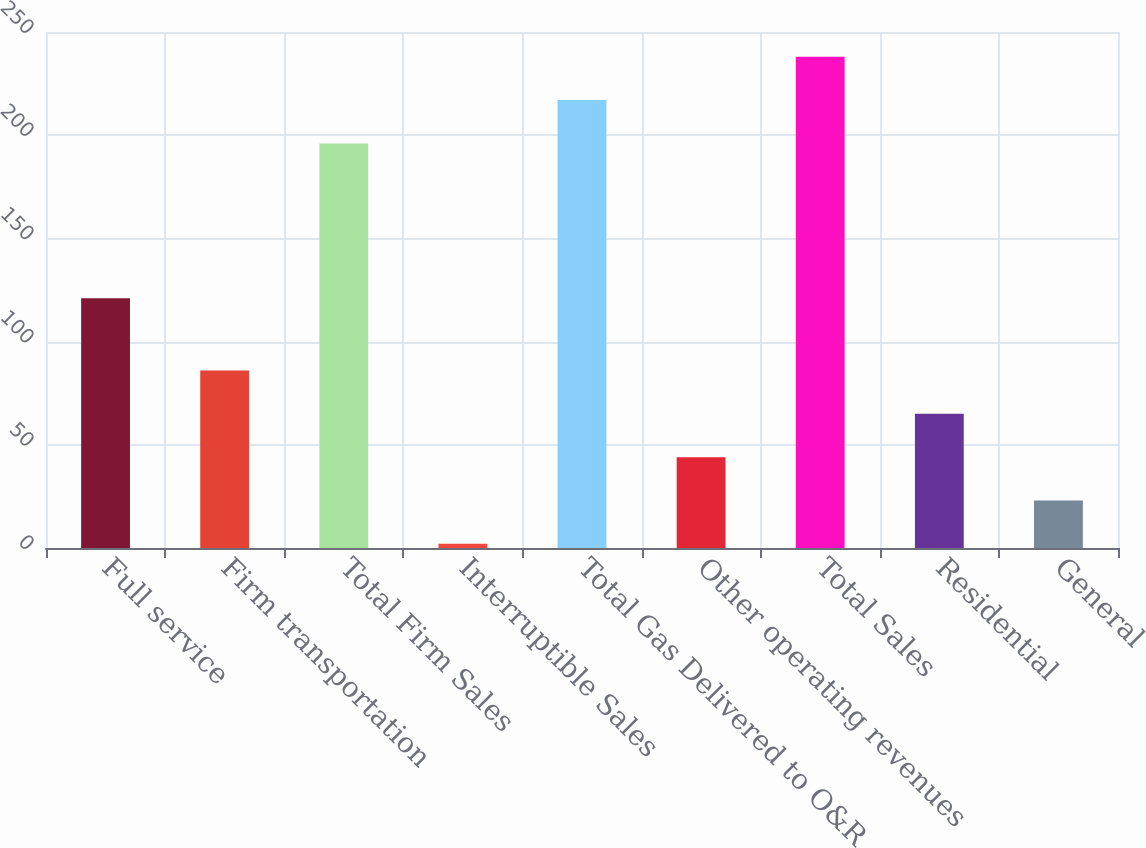<chart> <loc_0><loc_0><loc_500><loc_500><bar_chart><fcel>Full service<fcel>Firm transportation<fcel>Total Firm Sales<fcel>Interruptible Sales<fcel>Total Gas Delivered to O&R<fcel>Other operating revenues<fcel>Total Sales<fcel>Residential<fcel>General<nl><fcel>121<fcel>86<fcel>196<fcel>2<fcel>217<fcel>44<fcel>238<fcel>65<fcel>23<nl></chart> 